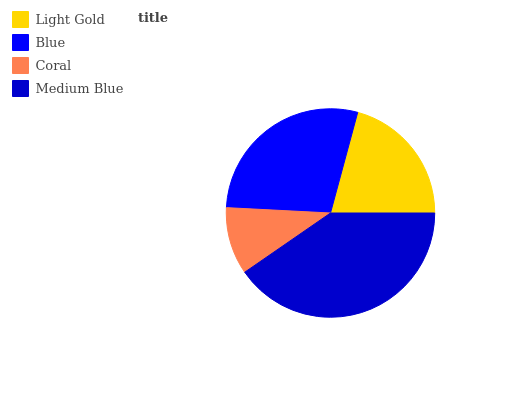Is Coral the minimum?
Answer yes or no. Yes. Is Medium Blue the maximum?
Answer yes or no. Yes. Is Blue the minimum?
Answer yes or no. No. Is Blue the maximum?
Answer yes or no. No. Is Blue greater than Light Gold?
Answer yes or no. Yes. Is Light Gold less than Blue?
Answer yes or no. Yes. Is Light Gold greater than Blue?
Answer yes or no. No. Is Blue less than Light Gold?
Answer yes or no. No. Is Blue the high median?
Answer yes or no. Yes. Is Light Gold the low median?
Answer yes or no. Yes. Is Light Gold the high median?
Answer yes or no. No. Is Medium Blue the low median?
Answer yes or no. No. 